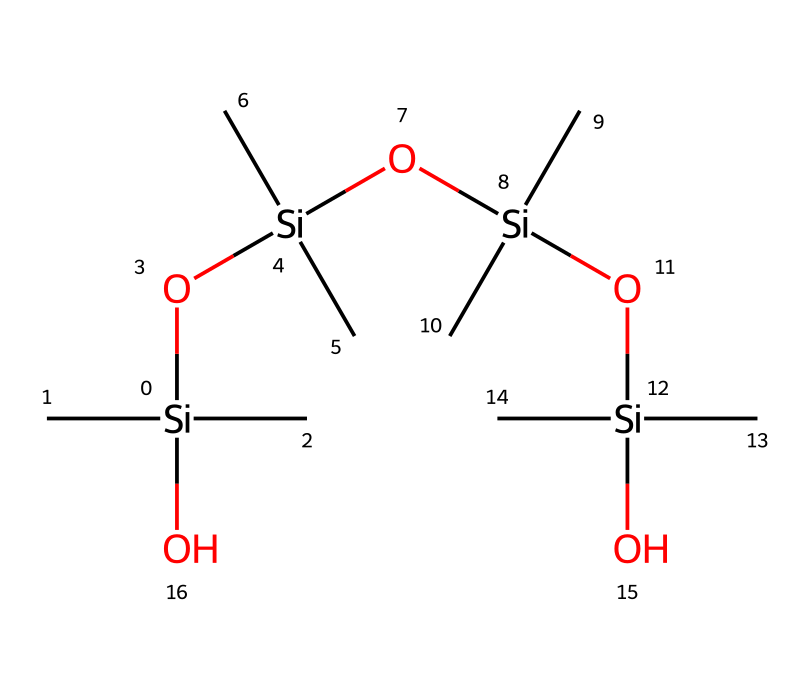How many silicon atoms are present in the structure? By analyzing the SMILES representation, we identify that there are four distinct silicon atoms represented by the "[Si]" notation, each of which is part of the repeating siloxane units.
Answer: four What is the primary functional group in this compound? The presence of the "[O]" connecting the silicon atoms indicates the siloxane functional group, characterized by a silicon-oxygen bond.
Answer: siloxane How many oxygen atoms are in the molecular structure? Counting the occurrences of the "[O]" notation in the provided SMILES, we find three oxygen atoms interspersed between the four silicon atoms.
Answer: three What type of bonding is primarily present in this chemical structure? The chemical structure primarily demonstrates covalent bonding, as indicated by the silicon-oxygen and silicon-carbon connections within the siloxane units.
Answer: covalent How does the presence of silicon affect the properties of this lubricant? The silicon atoms in the structure enhance lubricity and provide stability to temperature changes and moisture resistance, which are critical for vocal cord lubricants.
Answer: increases stability What is the impact of alkyl groups on the viscosity of this lubricant? The alkyl groups, represented by "(C)(C)", increase the hydrophobic nature of the siloxane structure, which significantly contributes to a higher viscosity and lubricity.
Answer: increases viscosity 